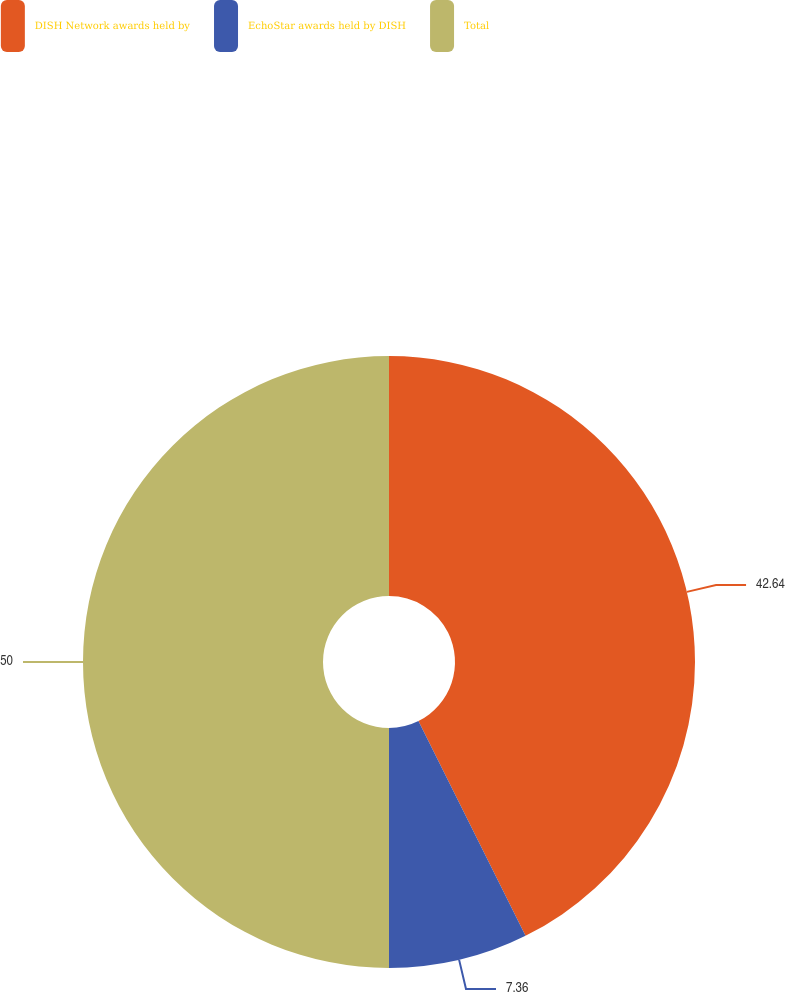Convert chart to OTSL. <chart><loc_0><loc_0><loc_500><loc_500><pie_chart><fcel>DISH Network awards held by<fcel>EchoStar awards held by DISH<fcel>Total<nl><fcel>42.64%<fcel>7.36%<fcel>50.0%<nl></chart> 